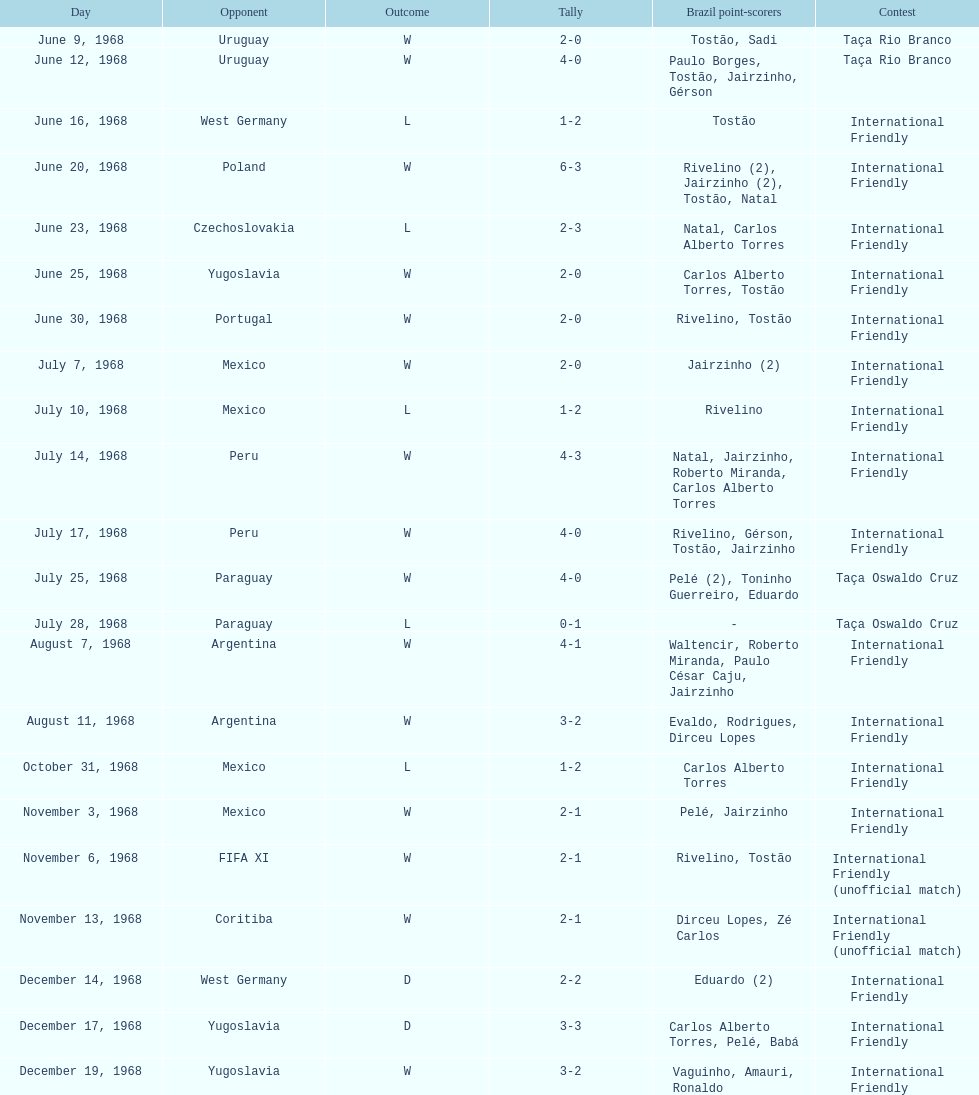How many times did brazil score during the game on november 6th? 2. 